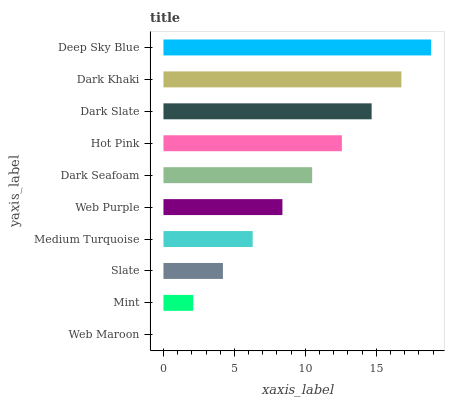Is Web Maroon the minimum?
Answer yes or no. Yes. Is Deep Sky Blue the maximum?
Answer yes or no. Yes. Is Mint the minimum?
Answer yes or no. No. Is Mint the maximum?
Answer yes or no. No. Is Mint greater than Web Maroon?
Answer yes or no. Yes. Is Web Maroon less than Mint?
Answer yes or no. Yes. Is Web Maroon greater than Mint?
Answer yes or no. No. Is Mint less than Web Maroon?
Answer yes or no. No. Is Dark Seafoam the high median?
Answer yes or no. Yes. Is Web Purple the low median?
Answer yes or no. Yes. Is Web Purple the high median?
Answer yes or no. No. Is Deep Sky Blue the low median?
Answer yes or no. No. 